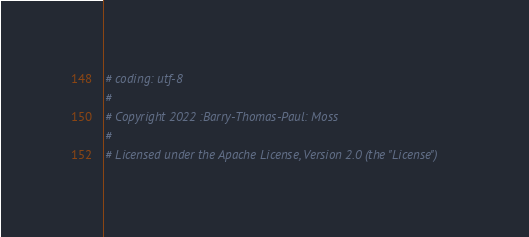Convert code to text. <code><loc_0><loc_0><loc_500><loc_500><_Python_># coding: utf-8
#
# Copyright 2022 :Barry-Thomas-Paul: Moss
#
# Licensed under the Apache License, Version 2.0 (the "License")</code> 